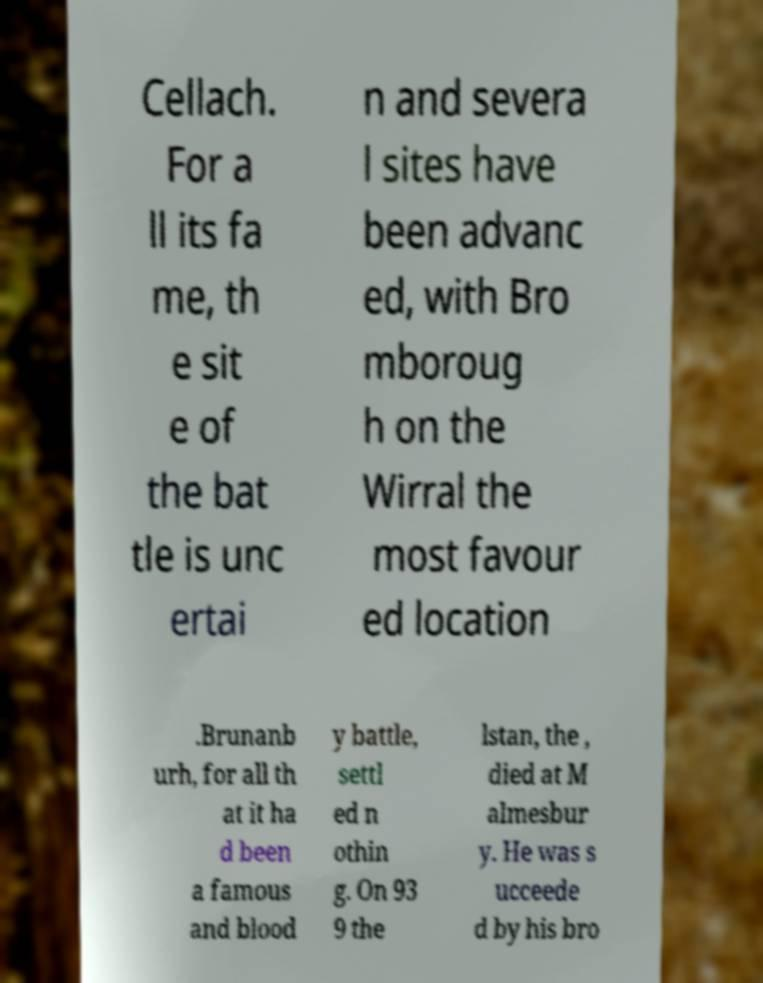Could you assist in decoding the text presented in this image and type it out clearly? Cellach. For a ll its fa me, th e sit e of the bat tle is unc ertai n and severa l sites have been advanc ed, with Bro mboroug h on the Wirral the most favour ed location .Brunanb urh, for all th at it ha d been a famous and blood y battle, settl ed n othin g. On 93 9 the lstan, the , died at M almesbur y. He was s ucceede d by his bro 